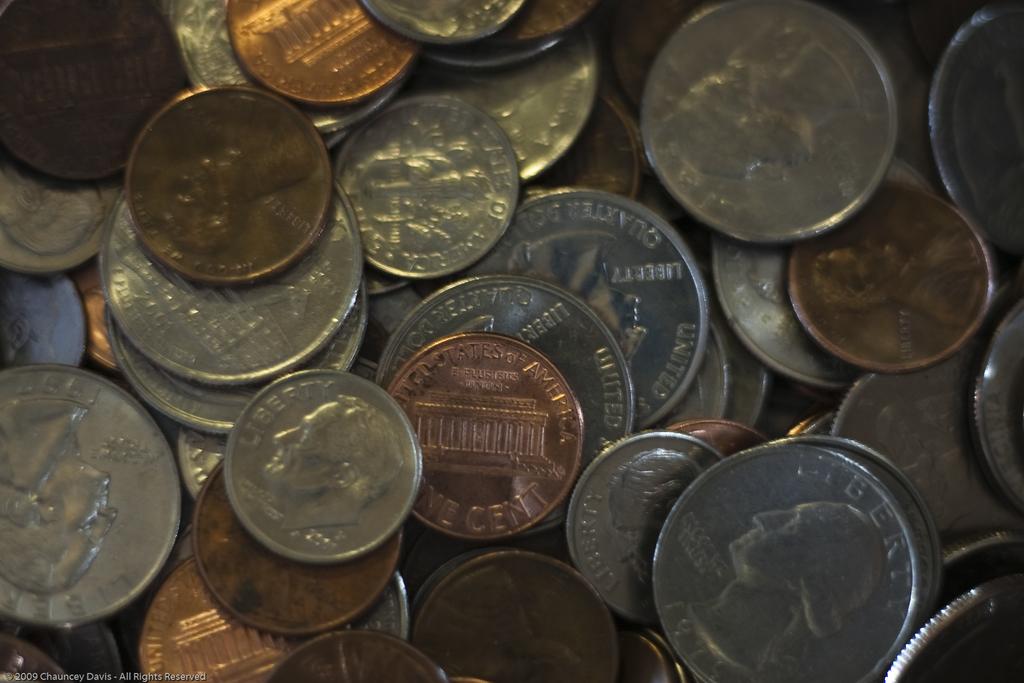What does the coin say?
Make the answer very short. Liberty. 